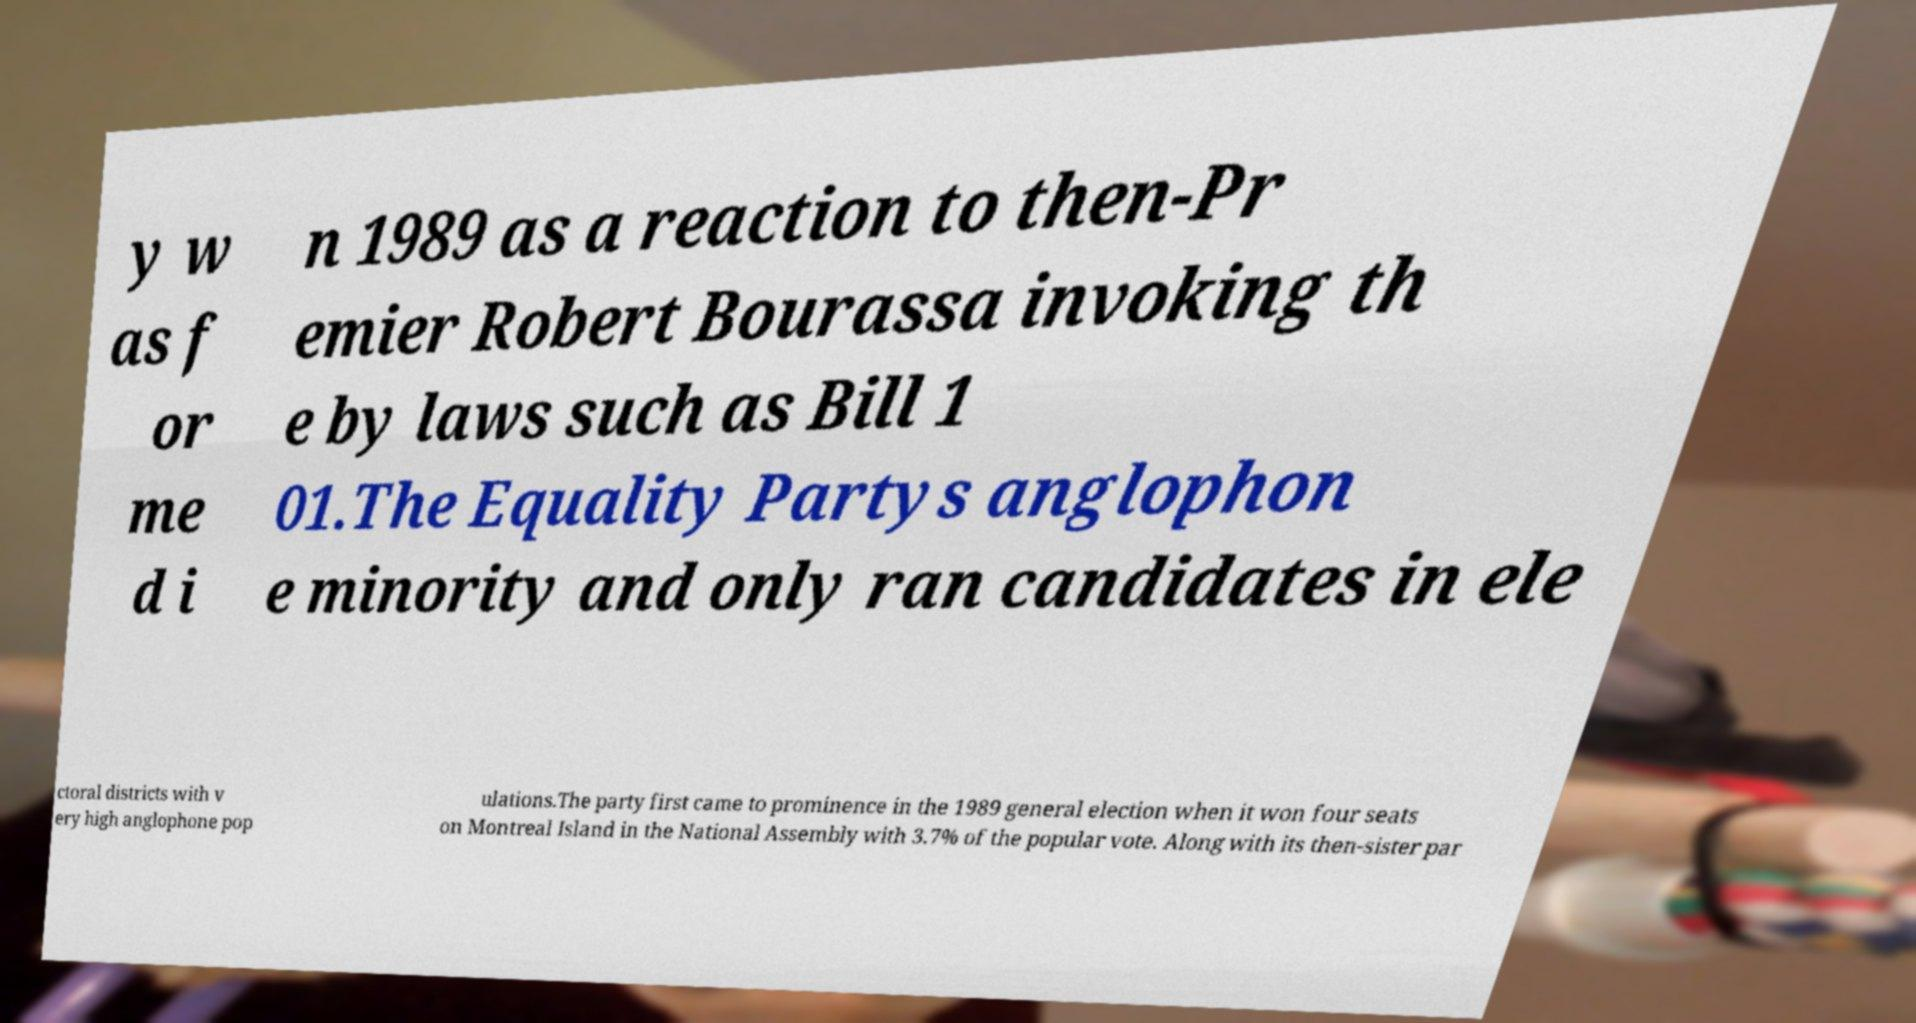Please identify and transcribe the text found in this image. y w as f or me d i n 1989 as a reaction to then-Pr emier Robert Bourassa invoking th e by laws such as Bill 1 01.The Equality Partys anglophon e minority and only ran candidates in ele ctoral districts with v ery high anglophone pop ulations.The party first came to prominence in the 1989 general election when it won four seats on Montreal Island in the National Assembly with 3.7% of the popular vote. Along with its then-sister par 